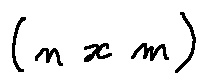<formula> <loc_0><loc_0><loc_500><loc_500>( n x m )</formula> 